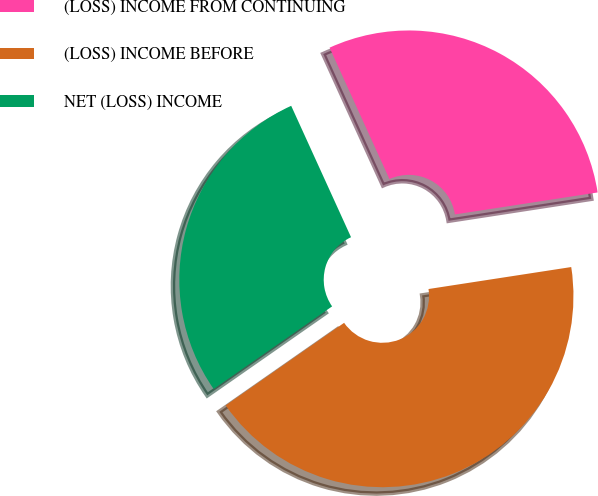<chart> <loc_0><loc_0><loc_500><loc_500><pie_chart><fcel>(LOSS) INCOME FROM CONTINUING<fcel>(LOSS) INCOME BEFORE<fcel>NET (LOSS) INCOME<nl><fcel>29.37%<fcel>42.74%<fcel>27.89%<nl></chart> 